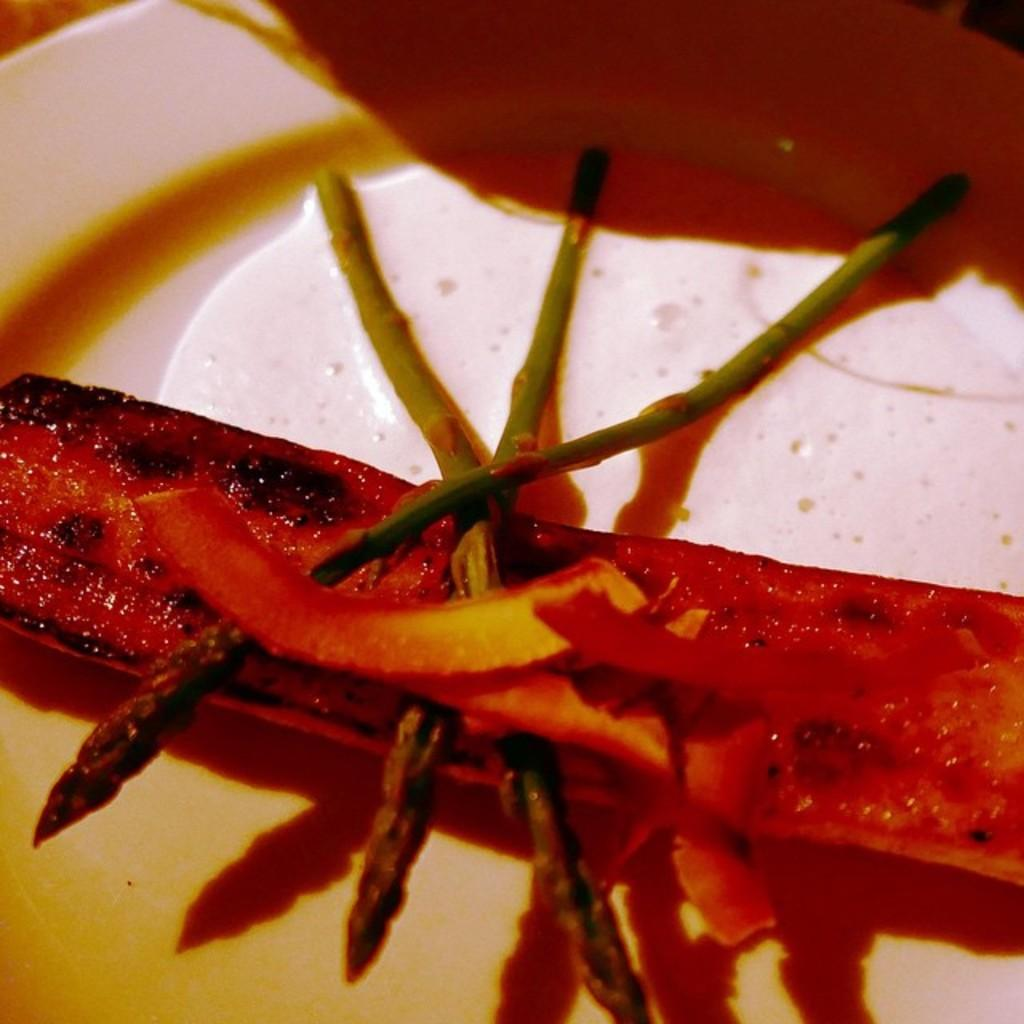What is the main subject of the image? There is a food item in the image. How is the food item presented in the image? The food item is in a plate. What type of nut can be seen in the image? There is no nut present in the image. How does the food item affect the stomach in the image? The image does not depict any action or reaction related to the stomach. 